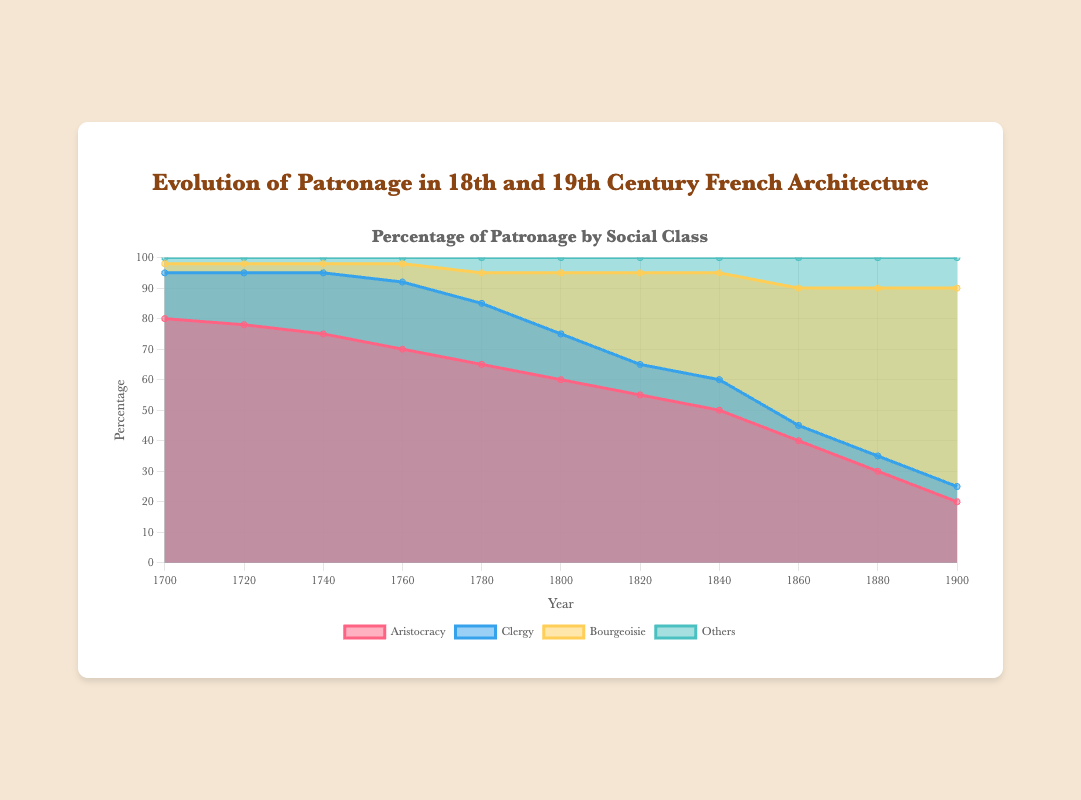What's the title of the chart? The title of the chart is displayed prominently at the top of the figure. It is "Evolution of Patronage in 18th and 19th Century French Architecture"
Answer: Evolution of Patronage in 18th and 19th Century French Architecture Which social class had the highest percentage of patronage in the year 1700? In the year 1700, the "Aristocracy" section of the area chart is the largest, indicating that the aristocracy had the highest percentage of patronage. The data shows the aristocracy at 80%.
Answer: Aristocracy How did the bourgeoisie's percentage of patronage change between 1800 and 1900? From the area chart, in 1800 the bourgeoisie's percentage was 20%, and in 1900 it was 65%. The change can be calculated as 65 - 20 = 45%.
Answer: Increased by 45% What was the trend in patronage by the clergy from 1700 to 1900? Observing the trend line for the clergy, it starts at 15% in 1700, rises to a peak of 22% in 1760, and then steadily declines to 5% by 1900. This demonstrates an overall decreasing trend.
Answer: Decreasing trend In which year did the aristocracy’s patronage percentage first fall below 70%? By examining the chart, the aristocracy's patronage percentage first falls below 70% in the year 1760, where it is recorded as 70%.
Answer: 1760 Compare the evolution of patronage between the clergy and the non-aristocratic categories from 1700 to 1900. From the chart, the clergy’s patronage initially rises to a peak before falling drastically. In contrast, the bourgeoisie increases steadily, while "Others" remains relatively stable but increases slightly toward the end. The clergy was overtaken by both the bourgeoisie and others in the later years.
Answer: Clergy decreased, others increased slightly, bourgeoisie increased significantly What is the difference in patronage percentage between the aristocracy and the bourgeoisie in 1880? In 1880, the aristocracy has a patronage percentage of 30% and the bourgeoisie has 55%. The difference is calculated as 55 - 30 = 25%.
Answer: 25% Which social class had the least change in their patronage percentage over the 200-year period? Looking at the figures over time, the "Others" category has the least change, beginning at 2%, experiencing slight increases, and ending at 10%, representing a relatively stable development.
Answer: Others By how much did the clergy's patronage decline from its peak in 1760 to the year 1900? The clergy’s patronage peaked at 22% in 1760 and declined to 5% by 1900. The amount of decline is calculated as 22% - 5% = 17%.
Answer: 17% 